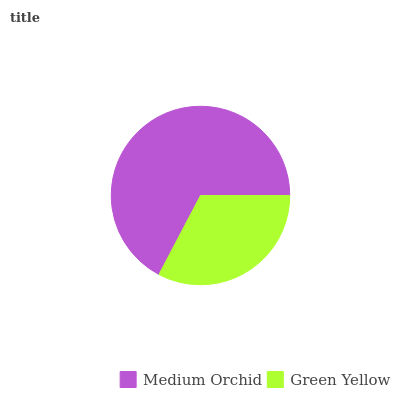Is Green Yellow the minimum?
Answer yes or no. Yes. Is Medium Orchid the maximum?
Answer yes or no. Yes. Is Green Yellow the maximum?
Answer yes or no. No. Is Medium Orchid greater than Green Yellow?
Answer yes or no. Yes. Is Green Yellow less than Medium Orchid?
Answer yes or no. Yes. Is Green Yellow greater than Medium Orchid?
Answer yes or no. No. Is Medium Orchid less than Green Yellow?
Answer yes or no. No. Is Medium Orchid the high median?
Answer yes or no. Yes. Is Green Yellow the low median?
Answer yes or no. Yes. Is Green Yellow the high median?
Answer yes or no. No. Is Medium Orchid the low median?
Answer yes or no. No. 